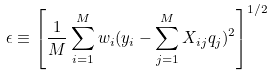Convert formula to latex. <formula><loc_0><loc_0><loc_500><loc_500>\epsilon \equiv \left [ \frac { 1 } { M } \sum _ { i = 1 } ^ { M } w _ { i } ( y _ { i } - \sum _ { j = 1 } ^ { M } X _ { i j } q _ { j } ) ^ { 2 } \right ] ^ { 1 / 2 }</formula> 